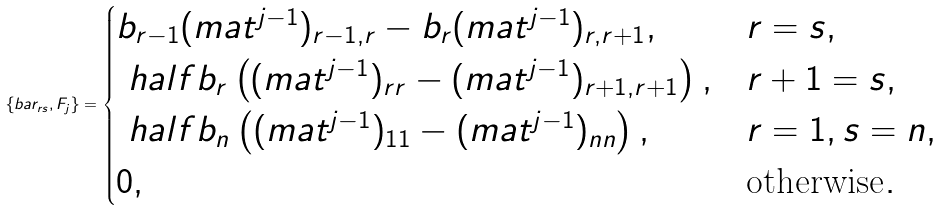<formula> <loc_0><loc_0><loc_500><loc_500>\{ \L b a r _ { r s } , F _ { j } \} = \begin{cases} b _ { r - 1 } ( \L m a t ^ { j - 1 } ) _ { r - 1 , r } - b _ { r } ( \L m a t ^ { j - 1 } ) _ { r , r + 1 } , & r = s , \\ \ h a l f b _ { r } \left ( ( \L m a t ^ { j - 1 } ) _ { r r } - ( \L m a t ^ { j - 1 } ) _ { r + 1 , r + 1 } \right ) , & r + 1 = s , \\ \ h a l f b _ { n } \left ( ( \L m a t ^ { j - 1 } ) _ { 1 1 } - ( \L m a t ^ { j - 1 } ) _ { n n } \right ) , & r = 1 , s = n , \\ 0 , & \text {otherwise} . \end{cases}</formula> 